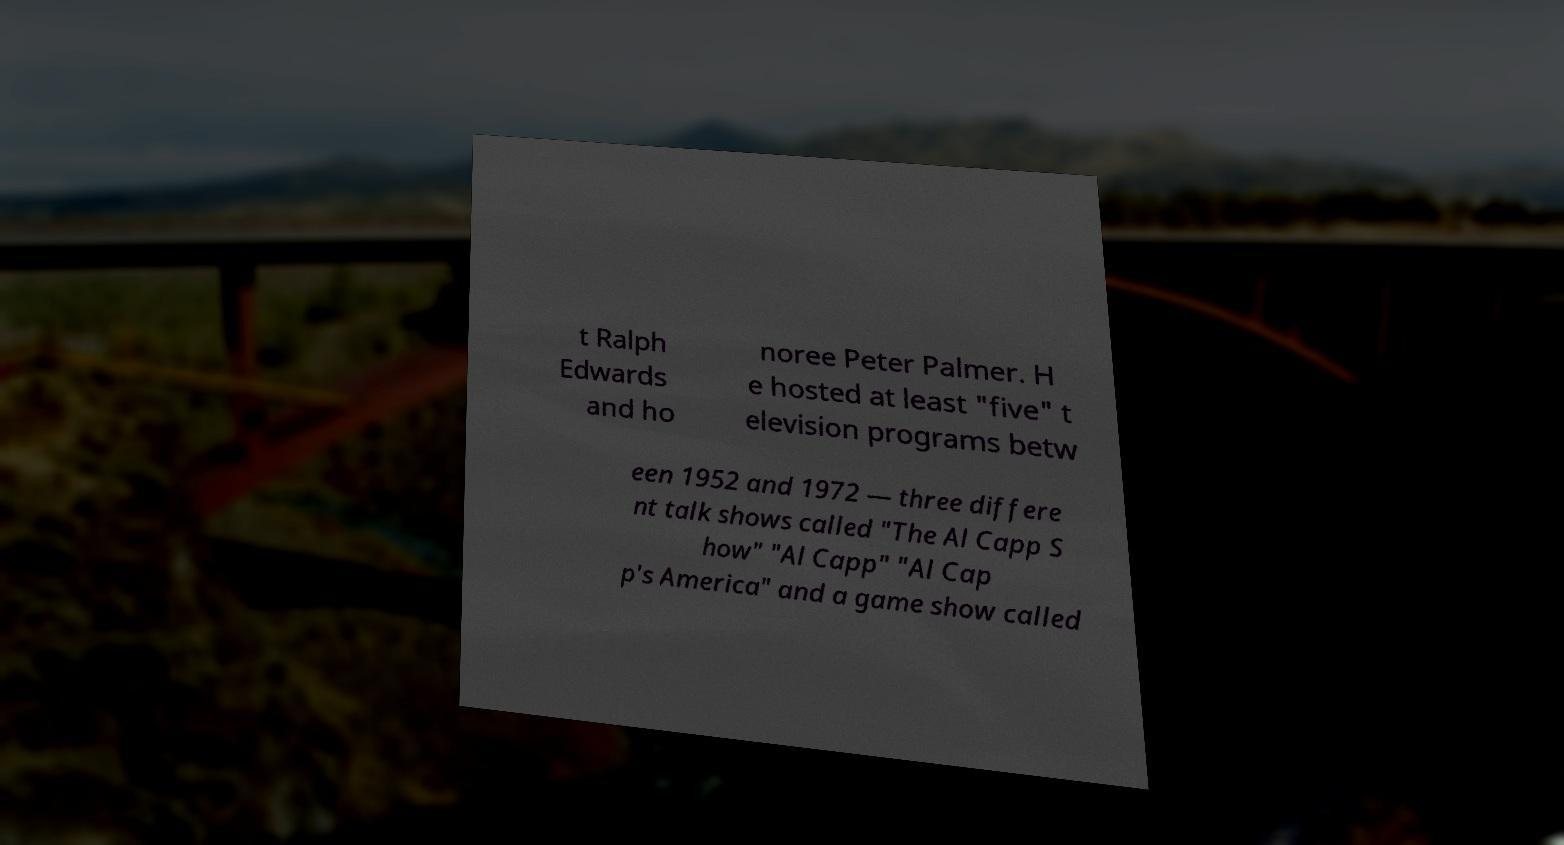Could you assist in decoding the text presented in this image and type it out clearly? t Ralph Edwards and ho noree Peter Palmer. H e hosted at least "five" t elevision programs betw een 1952 and 1972 — three differe nt talk shows called "The Al Capp S how" "Al Capp" "Al Cap p's America" and a game show called 